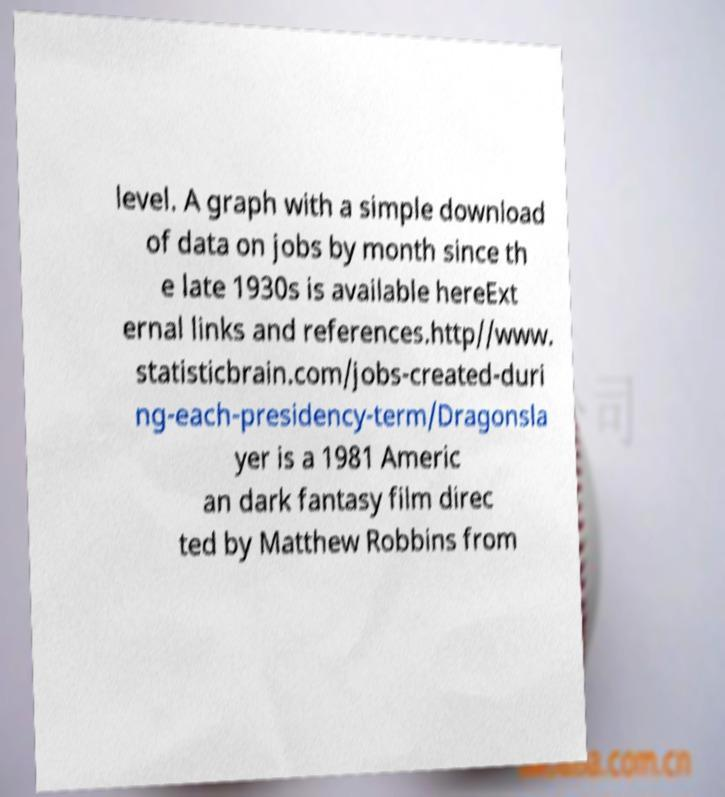There's text embedded in this image that I need extracted. Can you transcribe it verbatim? level. A graph with a simple download of data on jobs by month since th e late 1930s is available hereExt ernal links and references.http//www. statisticbrain.com/jobs-created-duri ng-each-presidency-term/Dragonsla yer is a 1981 Americ an dark fantasy film direc ted by Matthew Robbins from 